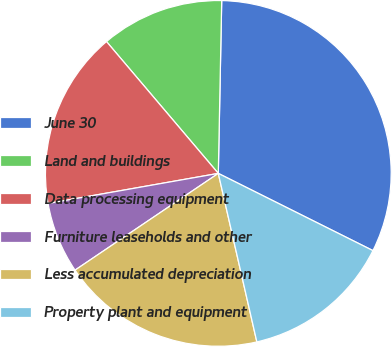<chart> <loc_0><loc_0><loc_500><loc_500><pie_chart><fcel>June 30<fcel>Land and buildings<fcel>Data processing equipment<fcel>Furniture leaseholds and other<fcel>Less accumulated depreciation<fcel>Property plant and equipment<nl><fcel>32.06%<fcel>11.51%<fcel>16.59%<fcel>6.67%<fcel>19.13%<fcel>14.05%<nl></chart> 